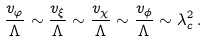Convert formula to latex. <formula><loc_0><loc_0><loc_500><loc_500>\frac { v _ { \varphi } } { \Lambda } \sim \frac { v _ { \xi } } { \Lambda } \sim \frac { v _ { \chi } } { \Lambda } \sim \frac { v _ { \phi } } { \Lambda } \sim \lambda ^ { 2 } _ { c } \, .</formula> 